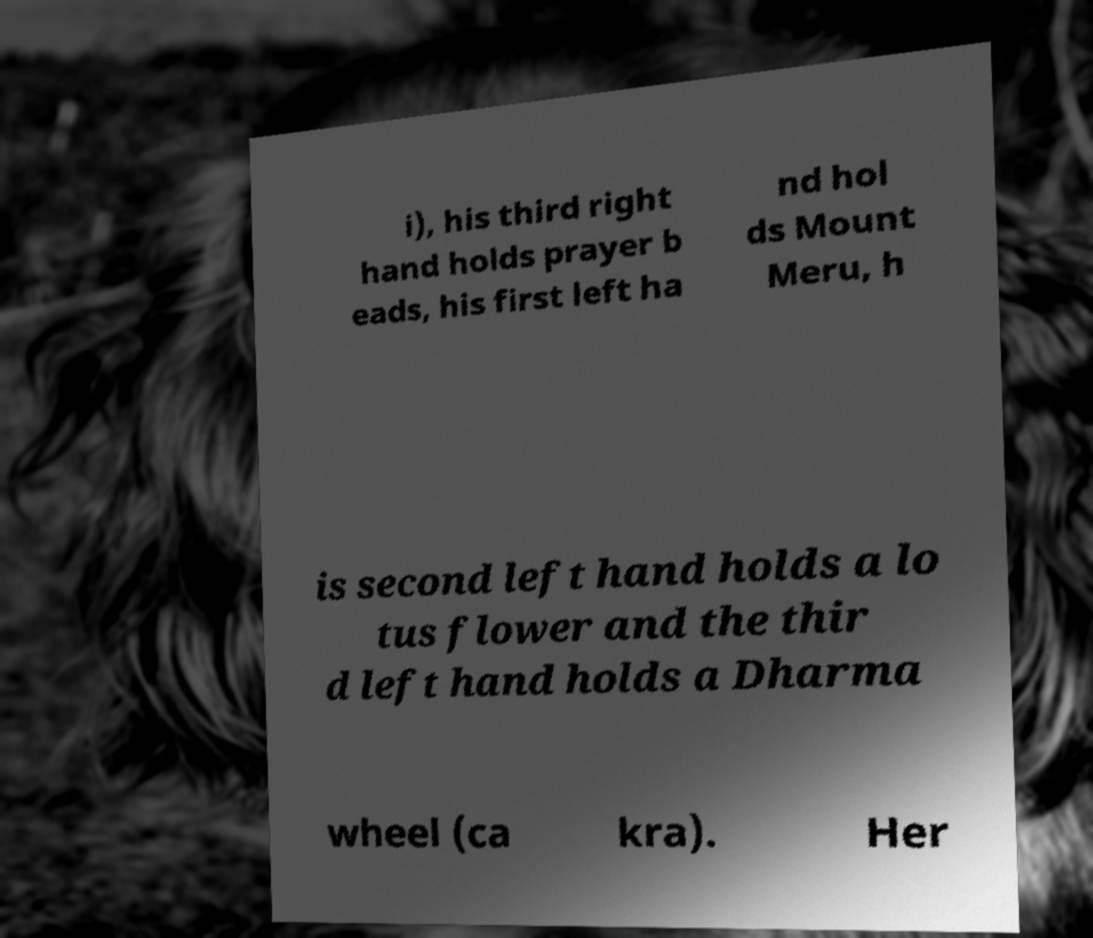There's text embedded in this image that I need extracted. Can you transcribe it verbatim? i), his third right hand holds prayer b eads, his first left ha nd hol ds Mount Meru, h is second left hand holds a lo tus flower and the thir d left hand holds a Dharma wheel (ca kra). Her 